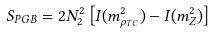Convert formula to latex. <formula><loc_0><loc_0><loc_500><loc_500>S _ { P G B } = 2 N _ { 2 } ^ { 2 } \left [ I ( m _ { \rho _ { T C } } ^ { 2 } ) - I ( m _ { Z } ^ { 2 } ) \right ]</formula> 